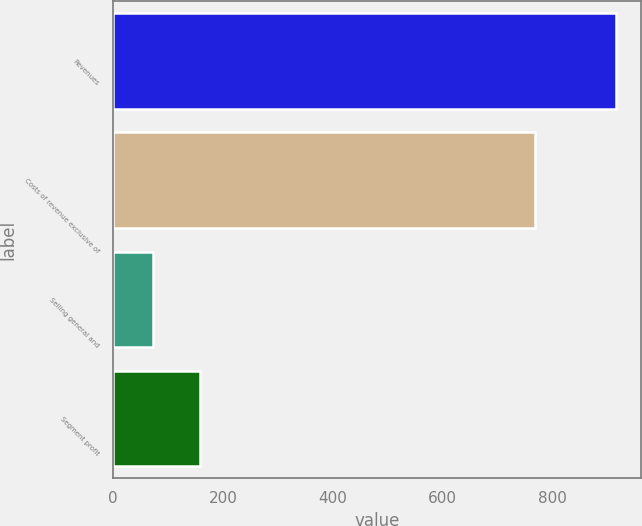Convert chart to OTSL. <chart><loc_0><loc_0><loc_500><loc_500><bar_chart><fcel>Revenues<fcel>Costs of revenue exclusive of<fcel>Selling general and<fcel>Segment profit<nl><fcel>915<fcel>768<fcel>73<fcel>157.2<nl></chart> 